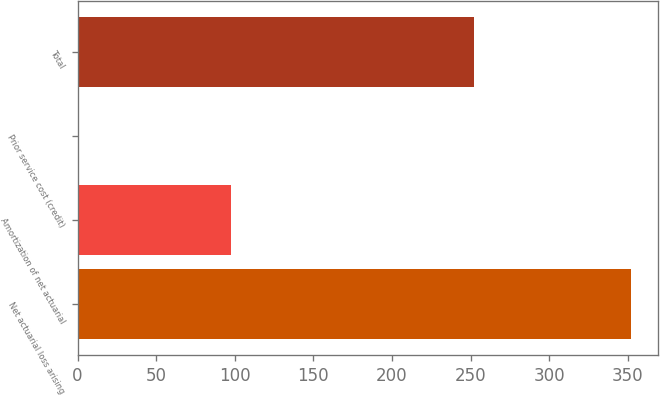Convert chart. <chart><loc_0><loc_0><loc_500><loc_500><bar_chart><fcel>Net actuarial loss arising<fcel>Amortization of net actuarial<fcel>Prior service cost (credit)<fcel>Total<nl><fcel>351.8<fcel>97.8<fcel>1.2<fcel>252.4<nl></chart> 